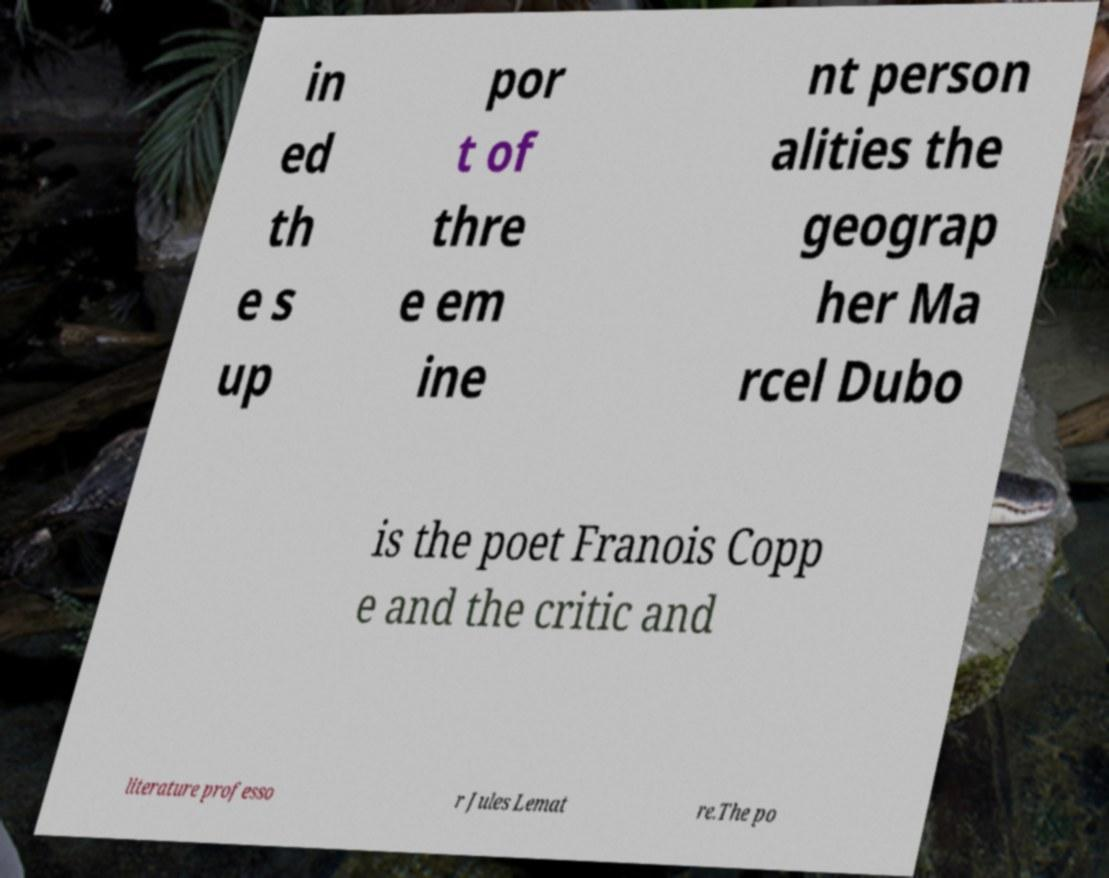Please read and relay the text visible in this image. What does it say? in ed th e s up por t of thre e em ine nt person alities the geograp her Ma rcel Dubo is the poet Franois Copp e and the critic and literature professo r Jules Lemat re.The po 